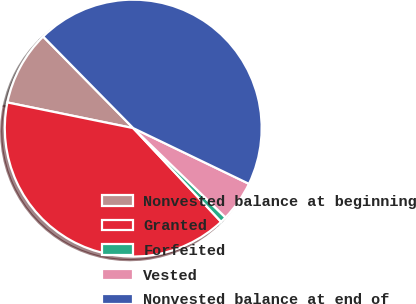Convert chart. <chart><loc_0><loc_0><loc_500><loc_500><pie_chart><fcel>Nonvested balance at beginning<fcel>Granted<fcel>Forfeited<fcel>Vested<fcel>Nonvested balance at end of<nl><fcel>9.43%<fcel>40.19%<fcel>0.77%<fcel>5.1%<fcel>44.51%<nl></chart> 